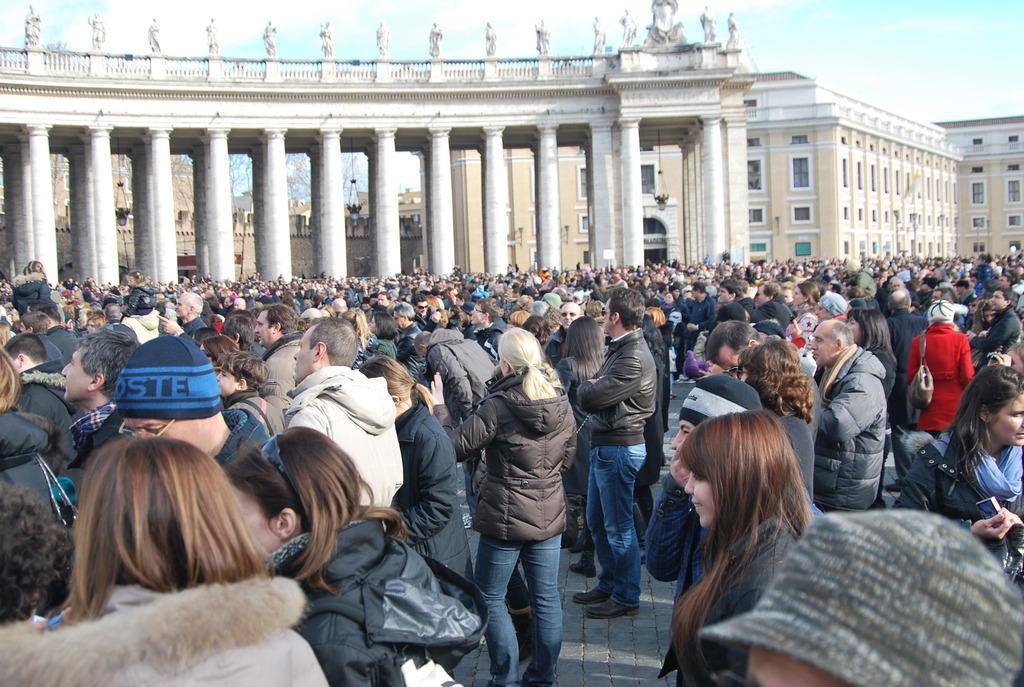Describe this image in one or two sentences. Here in this picture we can see number of people standing on the ground over there and we can see buildings present all over there and we can see windows on the building over there and we can also see clouds in the sky. 